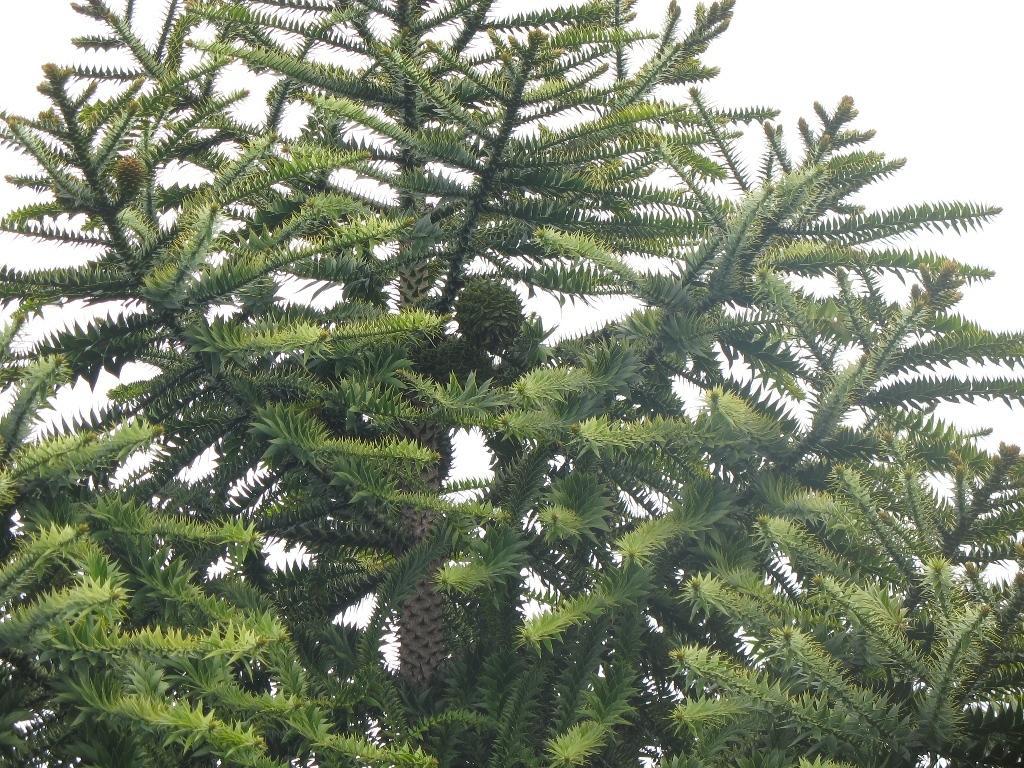Describe this image in one or two sentences. Here we can see trees and there is a white background. 